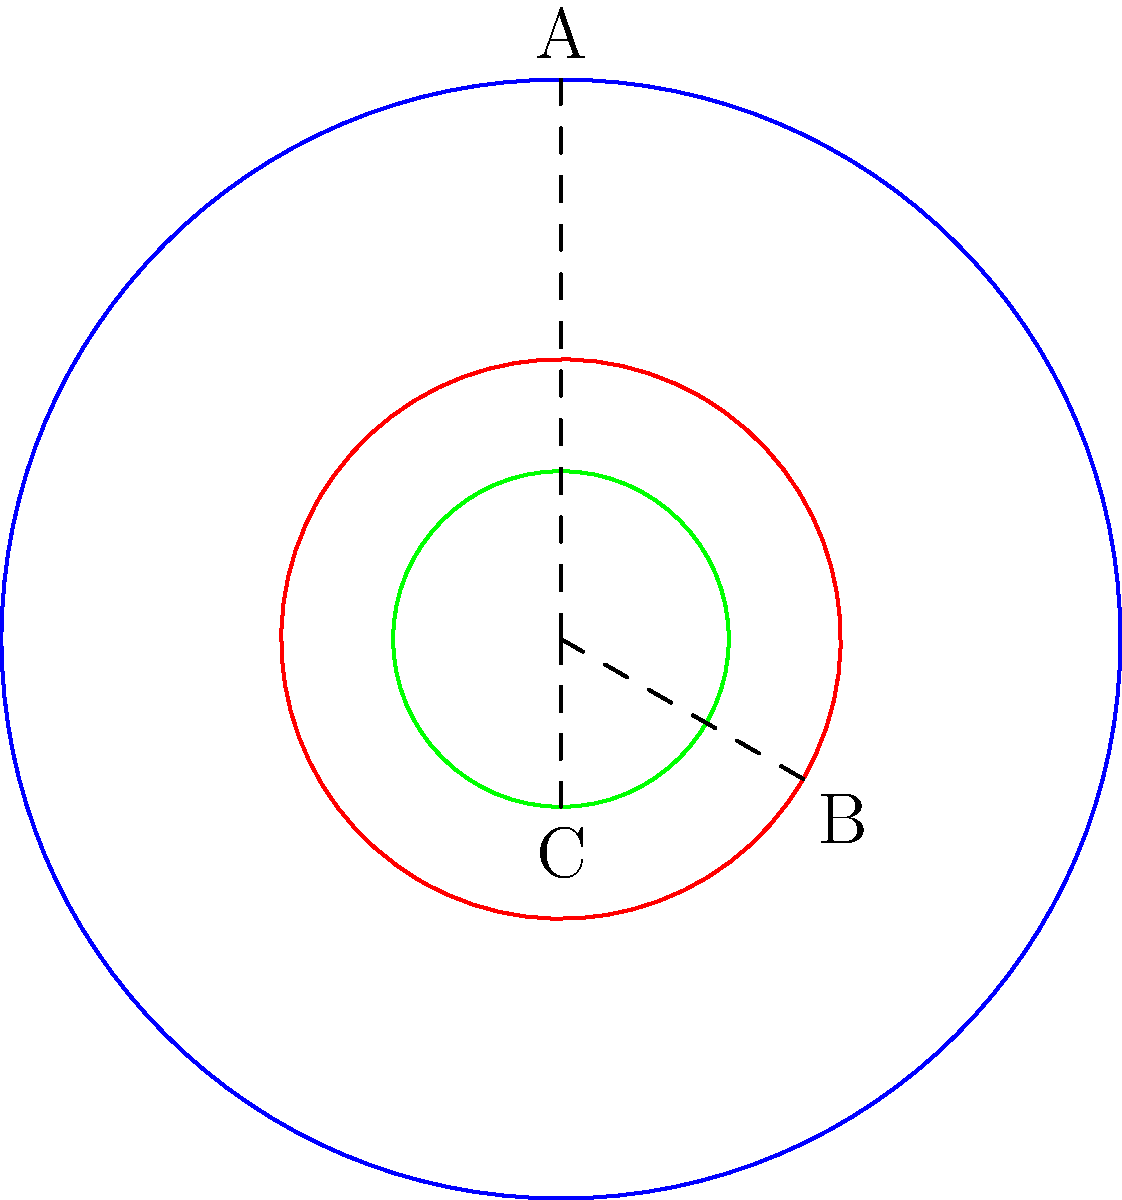A patented machine consists of three gears represented by circles A, B, and C. If gear A makes one complete rotation clockwise, how many complete rotations will gear C make, and in which direction? To solve this problem, we need to follow these steps:

1. Determine the relative sizes of the gears:
   - Gear A (blue) has a radius of 1 unit
   - Gear B (red) has a radius of 0.5 units
   - Gear C (green) has a radius of 0.3 units

2. Calculate the gear ratios:
   - Ratio of A to B: $\frac{r_A}{r_B} = \frac{1}{0.5} = 2$
   - Ratio of B to C: $\frac{r_B}{r_C} = \frac{0.5}{0.3} = \frac{5}{3}$

3. Determine the rotation of gear B:
   - When A rotates once clockwise, B rotates twice counterclockwise

4. Determine the rotation of gear C:
   - When B rotates twice counterclockwise, C rotates $2 \times \frac{5}{3} = \frac{10}{3}$ times clockwise

5. Simplify the final rotation:
   - $\frac{10}{3}$ rotations = 3 and $\frac{1}{3}$ rotations

Therefore, when gear A makes one complete rotation clockwise, gear C will make 3 and $\frac{1}{3}$ rotations clockwise.
Answer: 3 and 1/3 rotations clockwise 